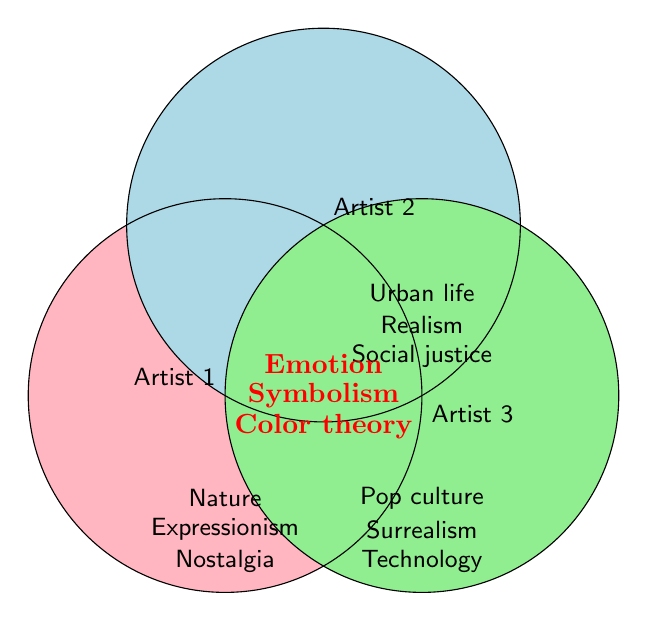What shared artistic theme is common among all three artists? The shared artistic themes are found in the overlapping section of all three circles in the Venn diagram. The text in this overlapping area includes "Symbolism", "Color theory", and "Emotion".
Answer: Symbolism, Color theory, Emotion Which artist includes "Technology" as their theme? By examining the area outside Artist 1's and Artist 2's circles but within Artist 3's circle, we can see that "Technology" is listed there.
Answer: Artist 3 How many themes are shared between Artist 1 and Artist 2 but not with Artist 3? By looking at the area where the circles of Artist 1 and Artist 2 overlap but exclude the part where Artist 3's circle overlaps, it can be deduced that there are no such themes specified in this Venn diagram.
Answer: None Which artist incorporates "Realism"? "Realism" is located inside the circle attributed to Artist 2 and no others, thus it is specific to Artist 2.
Answer: Artist 2 